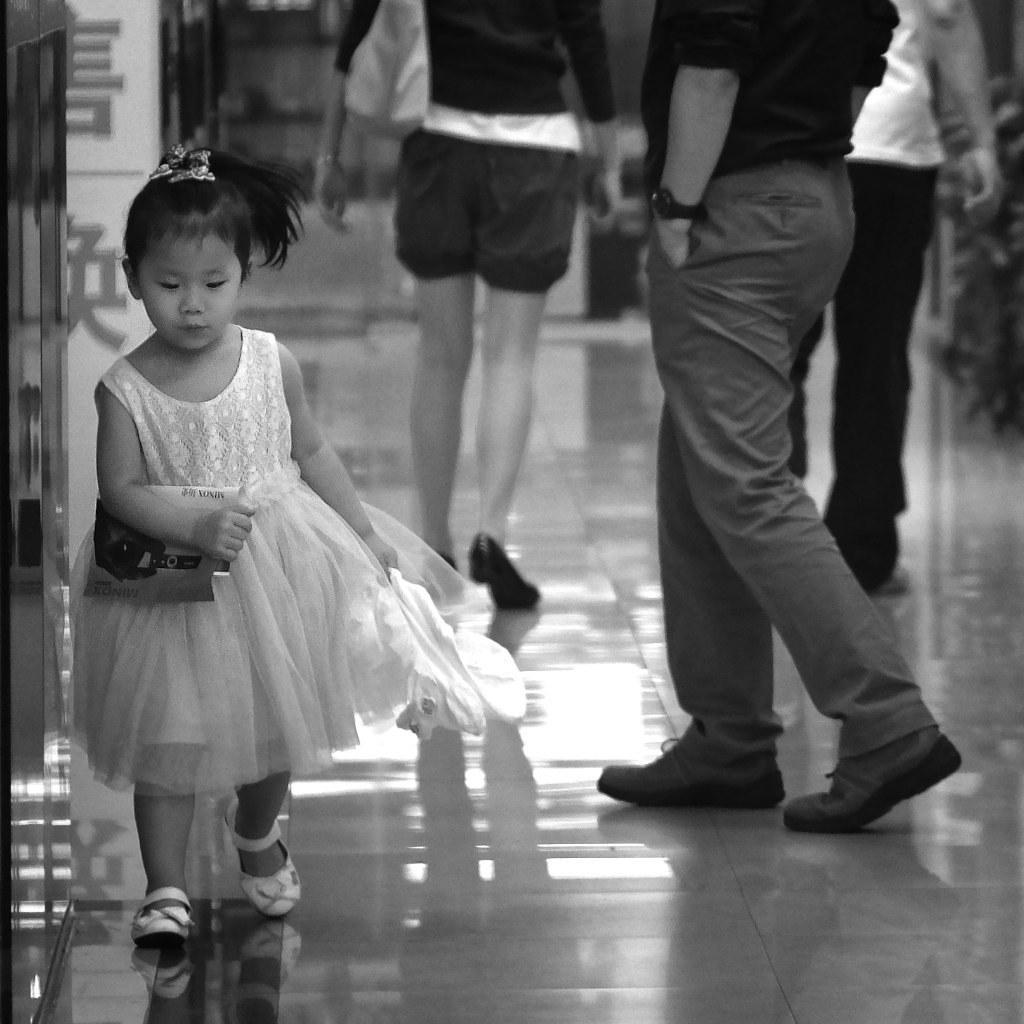Please provide a concise description of this image. In this image I can see the person walking. In the background I can see few other people and the image is in black and white. 